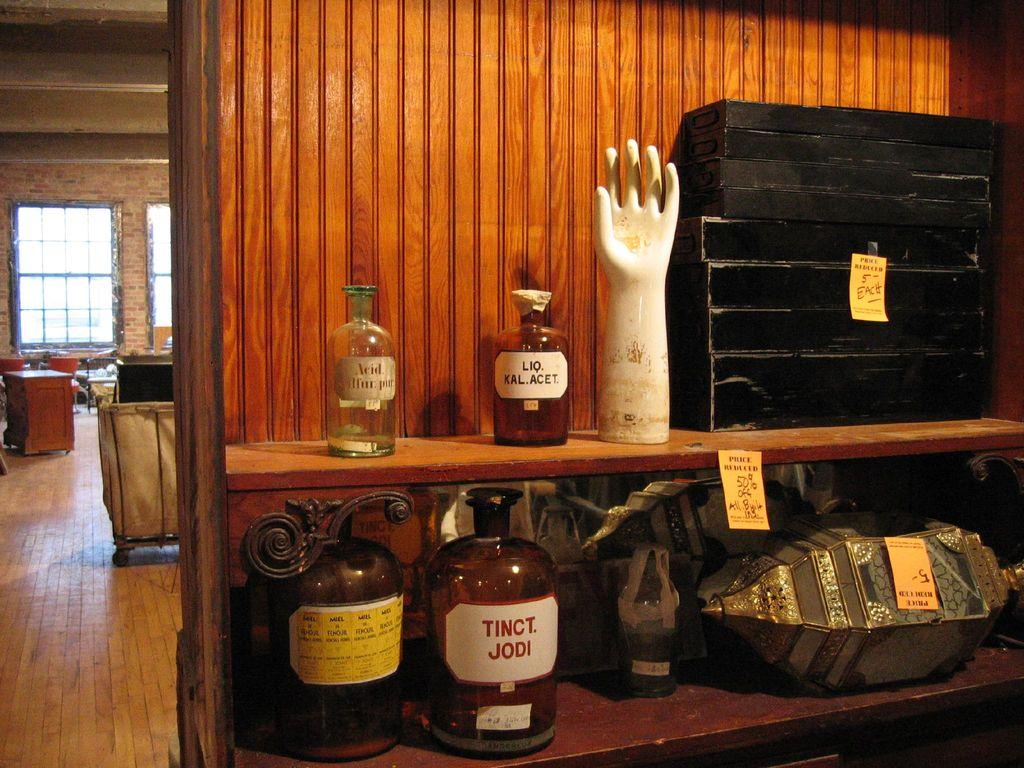What type of wall is visible in the image? There is a wooden wall with racks in the image. What is stored on the racks? There are bottles, a statue of a hand, a trunk box, and other items on the racks. Can you describe the statue on the racks? The statue is of a hand. What is located in the background of the image? There is a window and tables in the background of the image. What type of rake is used to clean the floor in the image? There is no rake present in the image; it features a wooden wall with racks, bottles, a statue of a hand, a trunk box, and other items on the racks, as well as a window and tables in the background. 